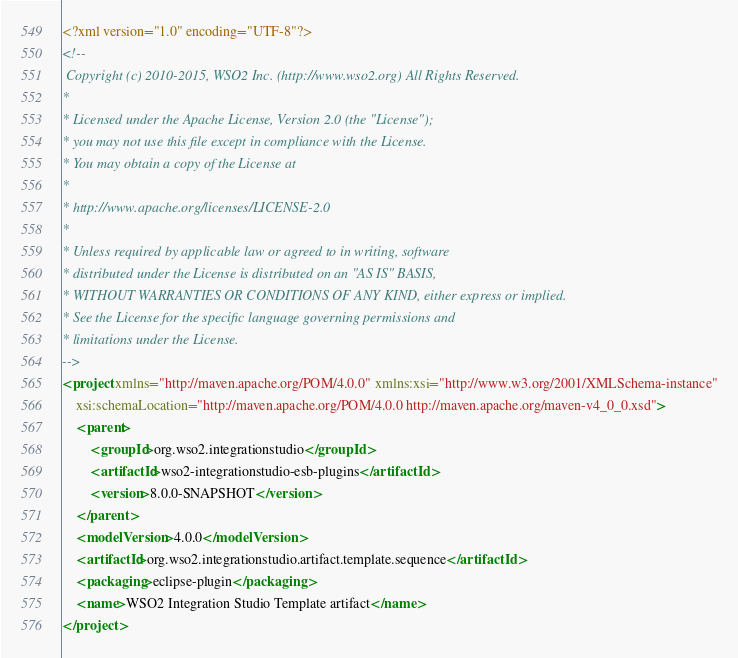<code> <loc_0><loc_0><loc_500><loc_500><_XML_><?xml version="1.0" encoding="UTF-8"?>
<!--
 Copyright (c) 2010-2015, WSO2 Inc. (http://www.wso2.org) All Rights Reserved.
*
* Licensed under the Apache License, Version 2.0 (the "License");
* you may not use this file except in compliance with the License.
* You may obtain a copy of the License at
*
* http://www.apache.org/licenses/LICENSE-2.0
*
* Unless required by applicable law or agreed to in writing, software
* distributed under the License is distributed on an "AS IS" BASIS,
* WITHOUT WARRANTIES OR CONDITIONS OF ANY KIND, either express or implied.
* See the License for the specific language governing permissions and
* limitations under the License.
-->
<project xmlns="http://maven.apache.org/POM/4.0.0" xmlns:xsi="http://www.w3.org/2001/XMLSchema-instance"
	xsi:schemaLocation="http://maven.apache.org/POM/4.0.0 http://maven.apache.org/maven-v4_0_0.xsd">
	<parent>
		<groupId>org.wso2.integrationstudio</groupId>
		<artifactId>wso2-integrationstudio-esb-plugins</artifactId>
		<version>8.0.0-SNAPSHOT</version>
	</parent>
	<modelVersion>4.0.0</modelVersion>
	<artifactId>org.wso2.integrationstudio.artifact.template.sequence</artifactId>
	<packaging>eclipse-plugin</packaging>
	<name>WSO2 Integration Studio Template artifact</name>
</project>
</code> 